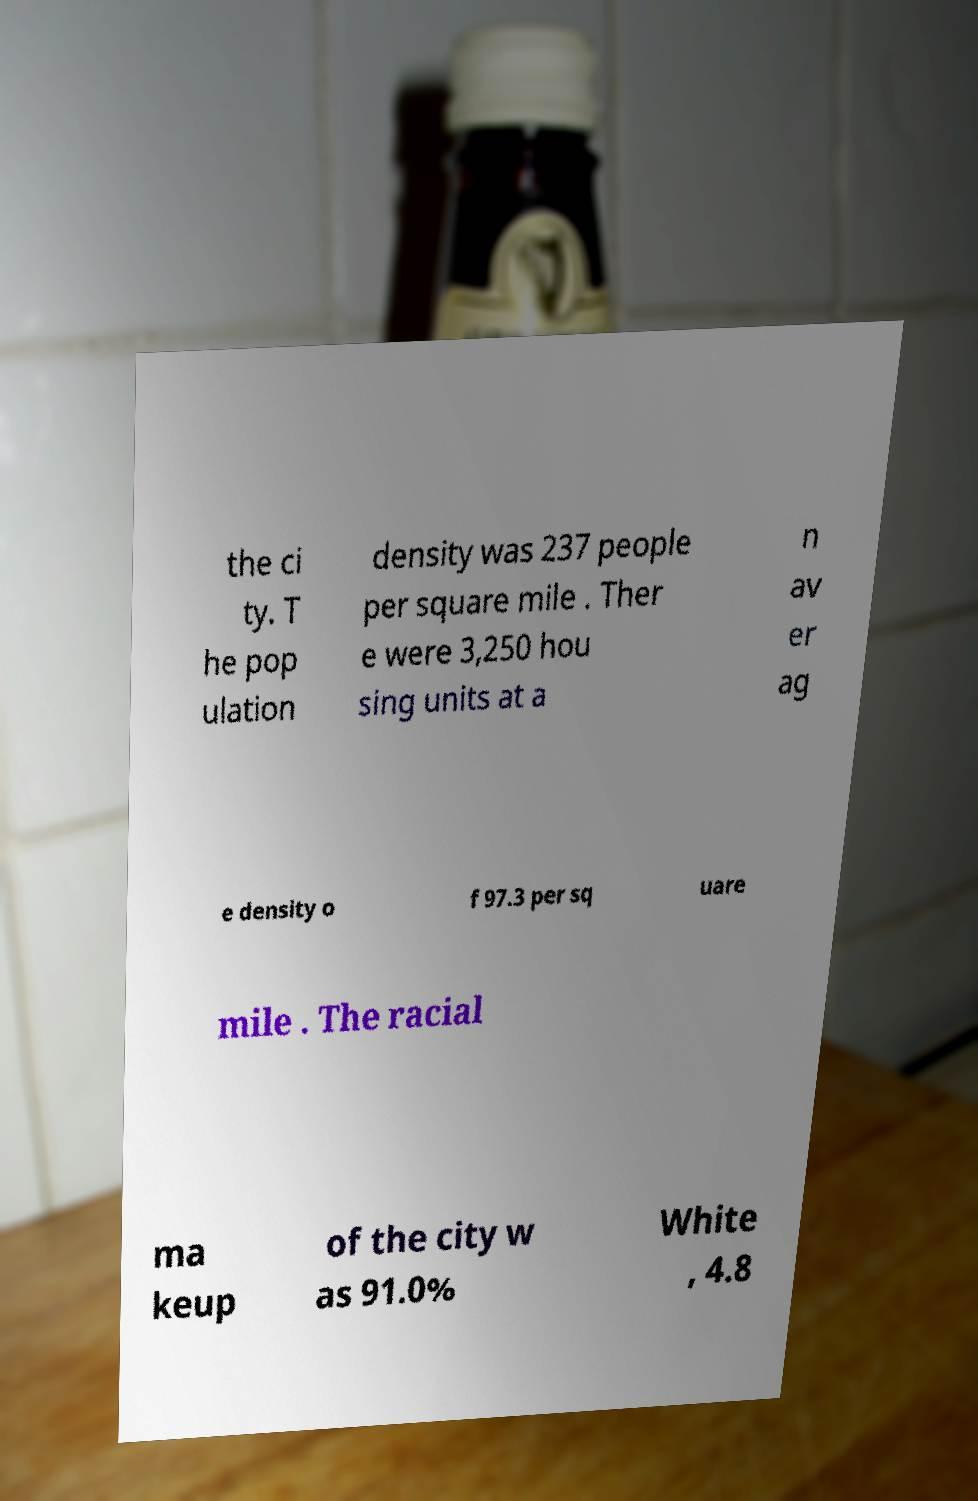There's text embedded in this image that I need extracted. Can you transcribe it verbatim? the ci ty. T he pop ulation density was 237 people per square mile . Ther e were 3,250 hou sing units at a n av er ag e density o f 97.3 per sq uare mile . The racial ma keup of the city w as 91.0% White , 4.8 